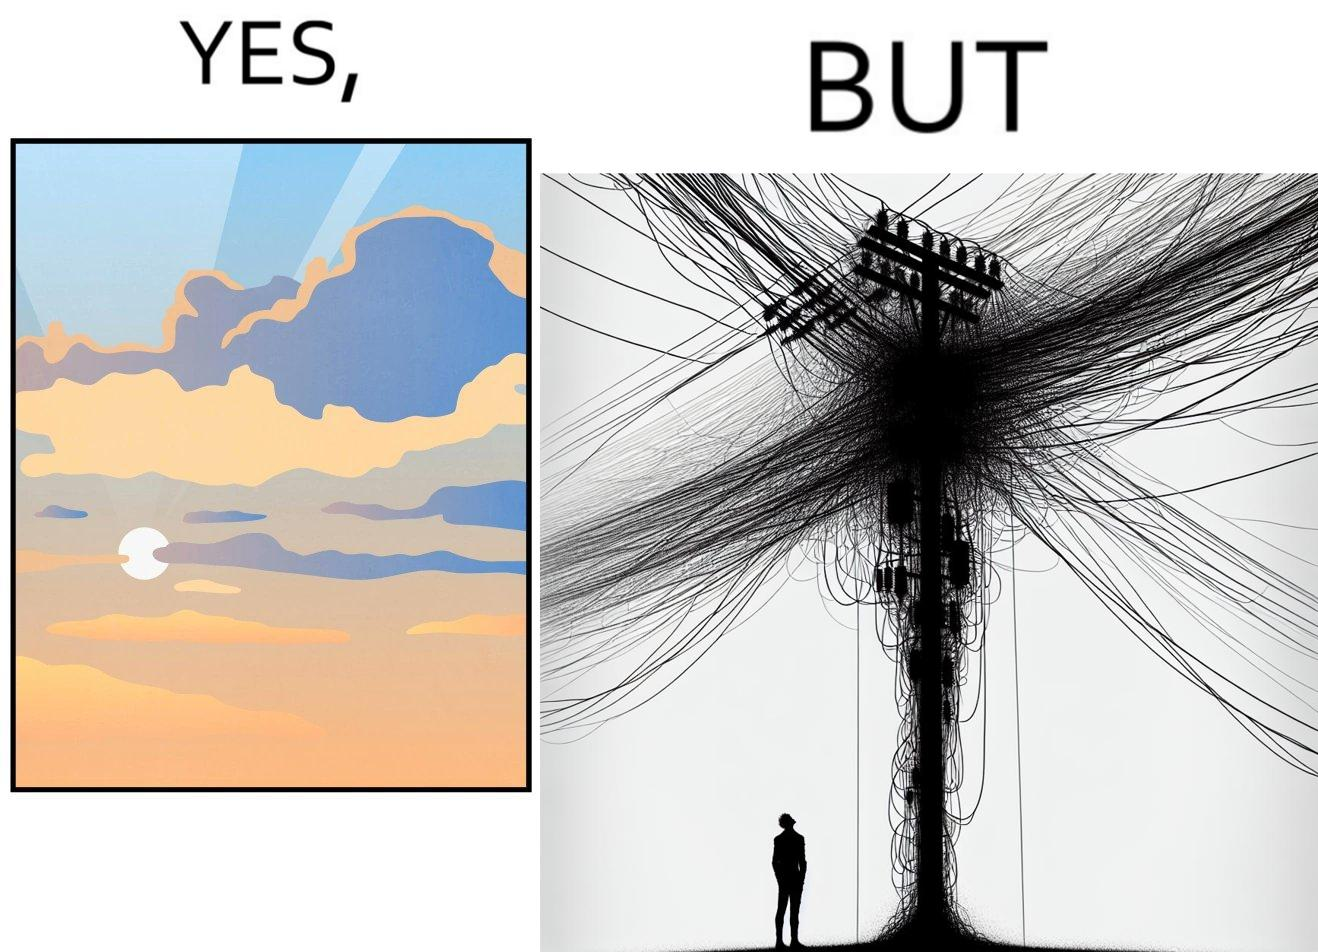Is this a satirical image? Yes, this image is satirical. 